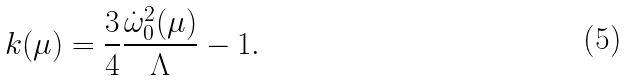<formula> <loc_0><loc_0><loc_500><loc_500>k ( \mu ) = \frac { 3 } { 4 } \frac { \dot { \omega } ^ { 2 } _ { 0 } ( \mu ) } { \Lambda } - 1 .</formula> 